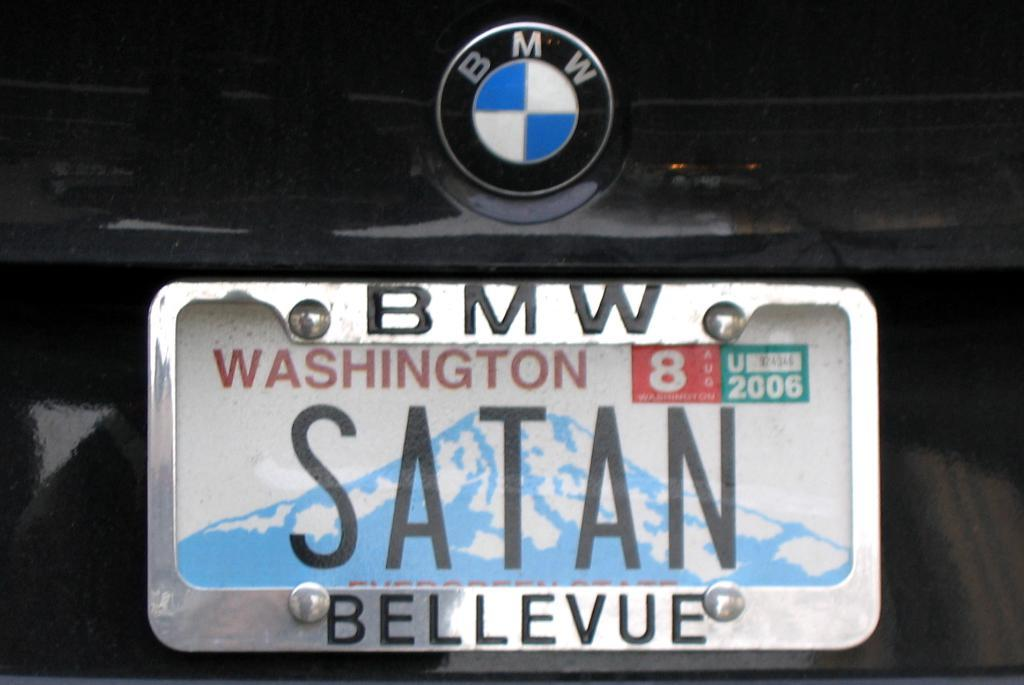<image>
Write a terse but informative summary of the picture. A Washington state license plate on a BMW that reads "Satan". 